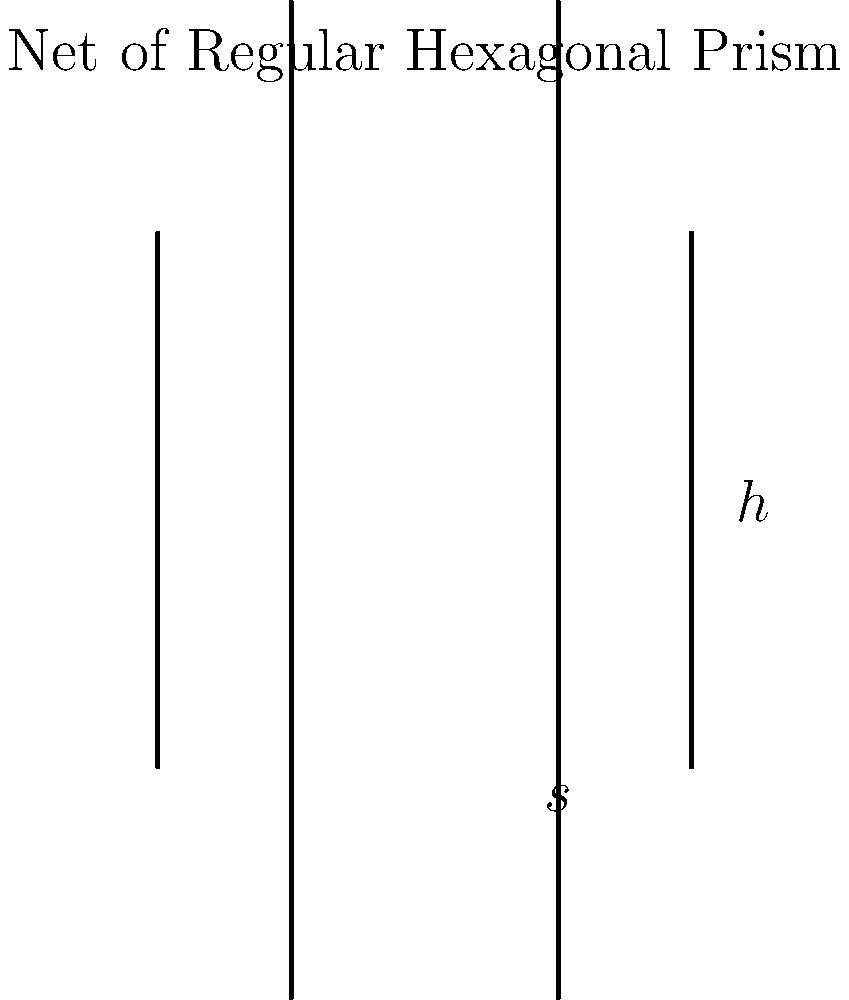A regular hexagonal prism has a side length of 6 cm and a height of 10 cm. Calculate the lateral surface area of the prism. To find the lateral surface area of a regular hexagonal prism, we need to follow these steps:

1) First, recall that the lateral surface area is the area of the rectangular faces that form the sides of the prism.

2) The number of rectangular faces in a hexagonal prism is equal to the number of sides of the hexagon, which is 6.

3) Each rectangular face has a width equal to the side length of the hexagon (s) and a height equal to the height of the prism (h).

4) The area of each rectangular face is given by $s \times h$.

5) Therefore, the lateral surface area is the sum of the areas of all 6 rectangular faces:

   Lateral Surface Area = $6 \times (s \times h)$

6) Substituting the given values:
   $s = 6$ cm
   $h = 10$ cm

7) Calculating:
   Lateral Surface Area = $6 \times (6 \text{ cm} \times 10 \text{ cm})$
                        = $6 \times 60 \text{ cm}^2$
                        = $360 \text{ cm}^2$

Thus, the lateral surface area of the hexagonal prism is 360 square centimeters.
Answer: $360 \text{ cm}^2$ 